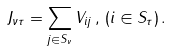<formula> <loc_0><loc_0><loc_500><loc_500>J _ { \nu \tau } = \sum _ { j \in S _ { \nu } } V _ { i j } \, , \, ( i \in S _ { \tau } ) \, .</formula> 